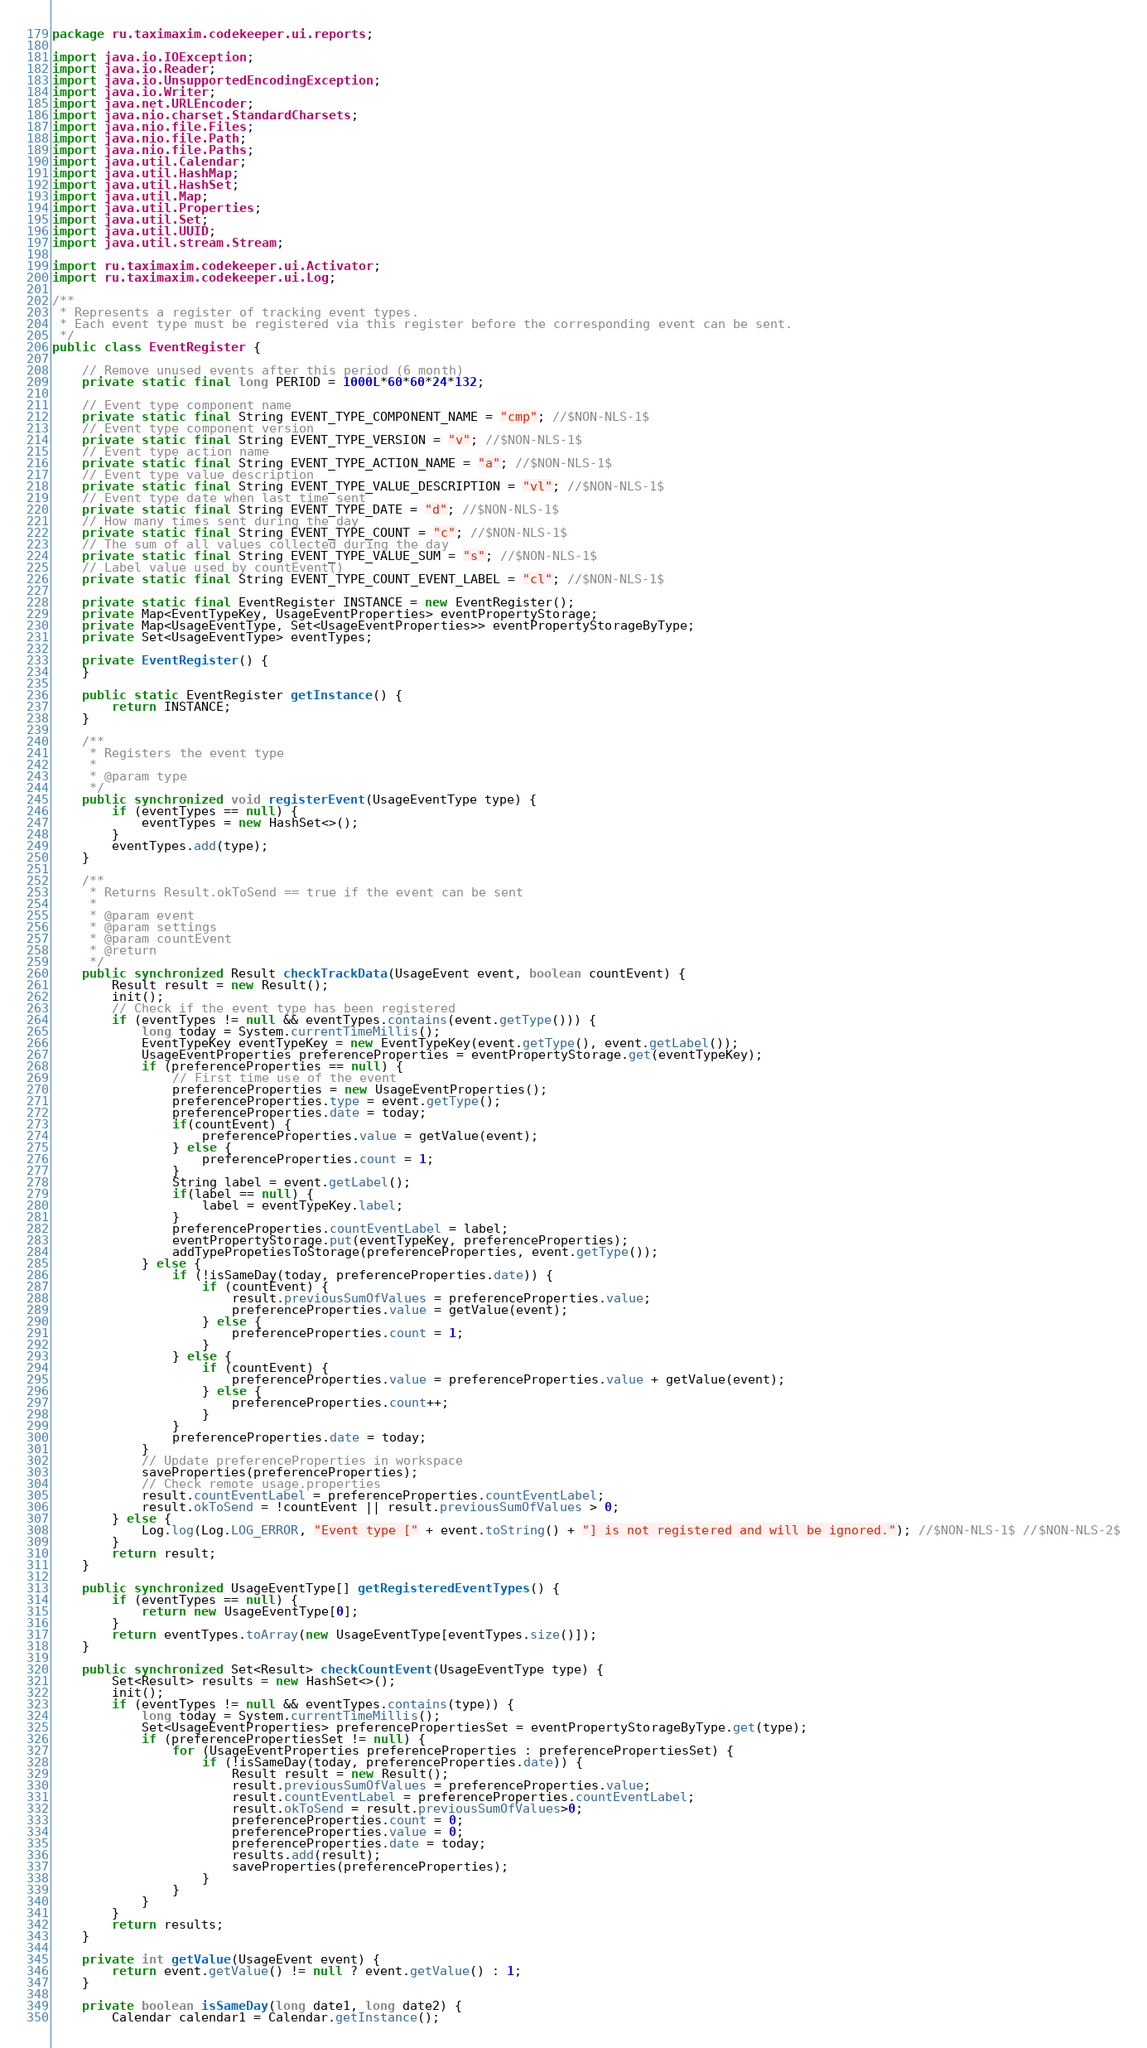<code> <loc_0><loc_0><loc_500><loc_500><_Java_>package ru.taximaxim.codekeeper.ui.reports;

import java.io.IOException;
import java.io.Reader;
import java.io.UnsupportedEncodingException;
import java.io.Writer;
import java.net.URLEncoder;
import java.nio.charset.StandardCharsets;
import java.nio.file.Files;
import java.nio.file.Path;
import java.nio.file.Paths;
import java.util.Calendar;
import java.util.HashMap;
import java.util.HashSet;
import java.util.Map;
import java.util.Properties;
import java.util.Set;
import java.util.UUID;
import java.util.stream.Stream;

import ru.taximaxim.codekeeper.ui.Activator;
import ru.taximaxim.codekeeper.ui.Log;

/**
 * Represents a register of tracking event types.
 * Each event type must be registered via this register before the corresponding event can be sent.
 */
public class EventRegister {

    // Remove unused events after this period (6 month)
    private static final long PERIOD = 1000L*60*60*24*132;

    // Event type component name
    private static final String EVENT_TYPE_COMPONENT_NAME = "cmp"; //$NON-NLS-1$
    // Event type component version
    private static final String EVENT_TYPE_VERSION = "v"; //$NON-NLS-1$
    // Event type action name
    private static final String EVENT_TYPE_ACTION_NAME = "a"; //$NON-NLS-1$
    // Event type value description
    private static final String EVENT_TYPE_VALUE_DESCRIPTION = "vl"; //$NON-NLS-1$
    // Event type date when last time sent
    private static final String EVENT_TYPE_DATE = "d"; //$NON-NLS-1$
    // How many times sent during the day
    private static final String EVENT_TYPE_COUNT = "c"; //$NON-NLS-1$
    // The sum of all values collected during the day
    private static final String EVENT_TYPE_VALUE_SUM = "s"; //$NON-NLS-1$
    // Label value used by countEvent()
    private static final String EVENT_TYPE_COUNT_EVENT_LABEL = "cl"; //$NON-NLS-1$

    private static final EventRegister INSTANCE = new EventRegister();
    private Map<EventTypeKey, UsageEventProperties> eventPropertyStorage;
    private Map<UsageEventType, Set<UsageEventProperties>> eventPropertyStorageByType;
    private Set<UsageEventType> eventTypes;

    private EventRegister() {
    }

    public static EventRegister getInstance() {
        return INSTANCE;
    }

    /**
     * Registers the event type
     *
     * @param type
     */
    public synchronized void registerEvent(UsageEventType type) {
        if (eventTypes == null) {
            eventTypes = new HashSet<>();
        }
        eventTypes.add(type);
    }

    /**
     * Returns Result.okToSend == true if the event can be sent
     *
     * @param event
     * @param settings
     * @param countEvent
     * @return
     */
    public synchronized Result checkTrackData(UsageEvent event, boolean countEvent) {
        Result result = new Result();
        init();
        // Check if the event type has been registered
        if (eventTypes != null && eventTypes.contains(event.getType())) {
            long today = System.currentTimeMillis();
            EventTypeKey eventTypeKey = new EventTypeKey(event.getType(), event.getLabel());
            UsageEventProperties preferenceProperties = eventPropertyStorage.get(eventTypeKey);
            if (preferenceProperties == null) {
                // First time use of the event
                preferenceProperties = new UsageEventProperties();
                preferenceProperties.type = event.getType();
                preferenceProperties.date = today;
                if(countEvent) {
                    preferenceProperties.value = getValue(event);
                } else {
                    preferenceProperties.count = 1;
                }
                String label = event.getLabel();
                if(label == null) {
                    label = eventTypeKey.label;
                }
                preferenceProperties.countEventLabel = label;
                eventPropertyStorage.put(eventTypeKey, preferenceProperties);
                addTypePropetiesToStorage(preferenceProperties, event.getType());
            } else {
                if (!isSameDay(today, preferenceProperties.date)) {
                    if (countEvent) {
                        result.previousSumOfValues = preferenceProperties.value;
                        preferenceProperties.value = getValue(event);
                    } else {
                        preferenceProperties.count = 1;
                    }
                } else {
                    if (countEvent) {
                        preferenceProperties.value = preferenceProperties.value + getValue(event);
                    } else {
                        preferenceProperties.count++;
                    }
                }
                preferenceProperties.date = today;
            }
            // Update preferenceProperties in workspace
            saveProperties(preferenceProperties);
            // Check remote usage.properties
            result.countEventLabel = preferenceProperties.countEventLabel;
            result.okToSend = !countEvent || result.previousSumOfValues > 0;
        } else {
            Log.log(Log.LOG_ERROR, "Event type [" + event.toString() + "] is not registered and will be ignored."); //$NON-NLS-1$ //$NON-NLS-2$
        }
        return result;
    }

    public synchronized UsageEventType[] getRegisteredEventTypes() {
        if (eventTypes == null) {
            return new UsageEventType[0];
        }
        return eventTypes.toArray(new UsageEventType[eventTypes.size()]);
    }

    public synchronized Set<Result> checkCountEvent(UsageEventType type) {
        Set<Result> results = new HashSet<>();
        init();
        if (eventTypes != null && eventTypes.contains(type)) {
            long today = System.currentTimeMillis();
            Set<UsageEventProperties> preferencePropertiesSet = eventPropertyStorageByType.get(type);
            if (preferencePropertiesSet != null) {
                for (UsageEventProperties preferenceProperties : preferencePropertiesSet) {
                    if (!isSameDay(today, preferenceProperties.date)) {
                        Result result = new Result();
                        result.previousSumOfValues = preferenceProperties.value;
                        result.countEventLabel = preferenceProperties.countEventLabel;
                        result.okToSend = result.previousSumOfValues>0;
                        preferenceProperties.count = 0;
                        preferenceProperties.value = 0;
                        preferenceProperties.date = today;
                        results.add(result);
                        saveProperties(preferenceProperties);
                    }
                }
            }
        }
        return results;
    }

    private int getValue(UsageEvent event) {
        return event.getValue() != null ? event.getValue() : 1;
    }

    private boolean isSameDay(long date1, long date2) {
        Calendar calendar1 = Calendar.getInstance();</code> 